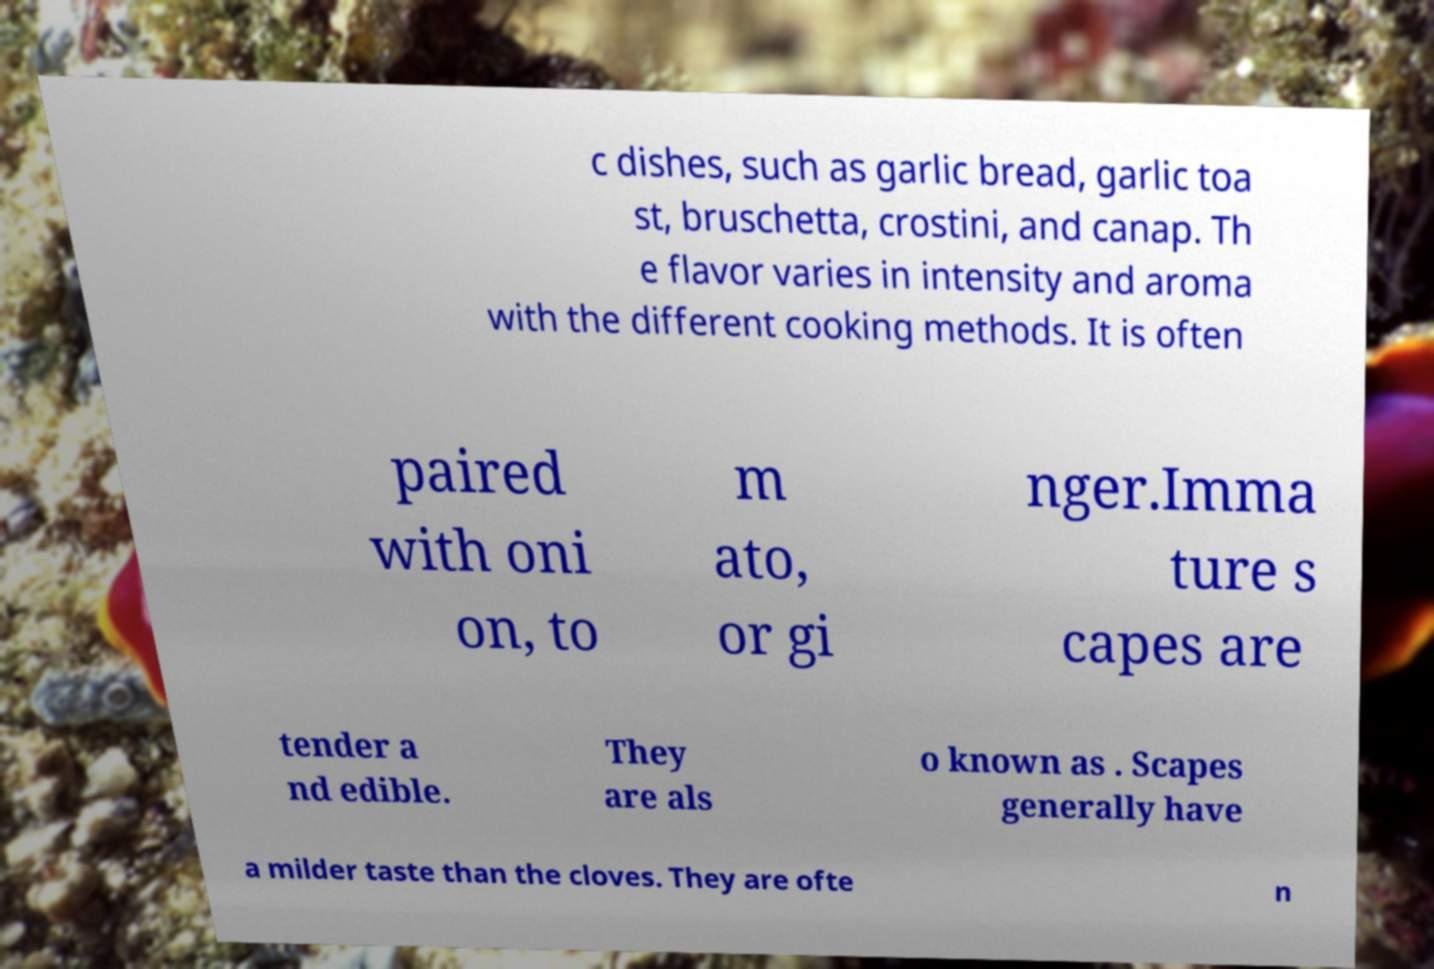Could you assist in decoding the text presented in this image and type it out clearly? c dishes, such as garlic bread, garlic toa st, bruschetta, crostini, and canap. Th e flavor varies in intensity and aroma with the different cooking methods. It is often paired with oni on, to m ato, or gi nger.Imma ture s capes are tender a nd edible. They are als o known as . Scapes generally have a milder taste than the cloves. They are ofte n 